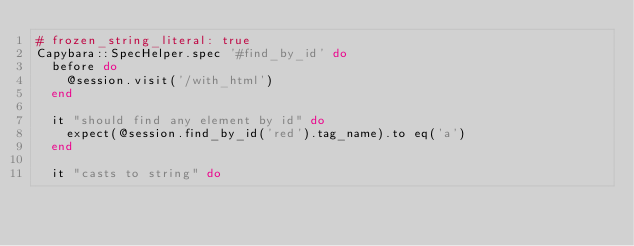Convert code to text. <code><loc_0><loc_0><loc_500><loc_500><_Ruby_># frozen_string_literal: true
Capybara::SpecHelper.spec '#find_by_id' do
  before do
    @session.visit('/with_html')
  end

  it "should find any element by id" do
    expect(@session.find_by_id('red').tag_name).to eq('a')
  end

  it "casts to string" do</code> 